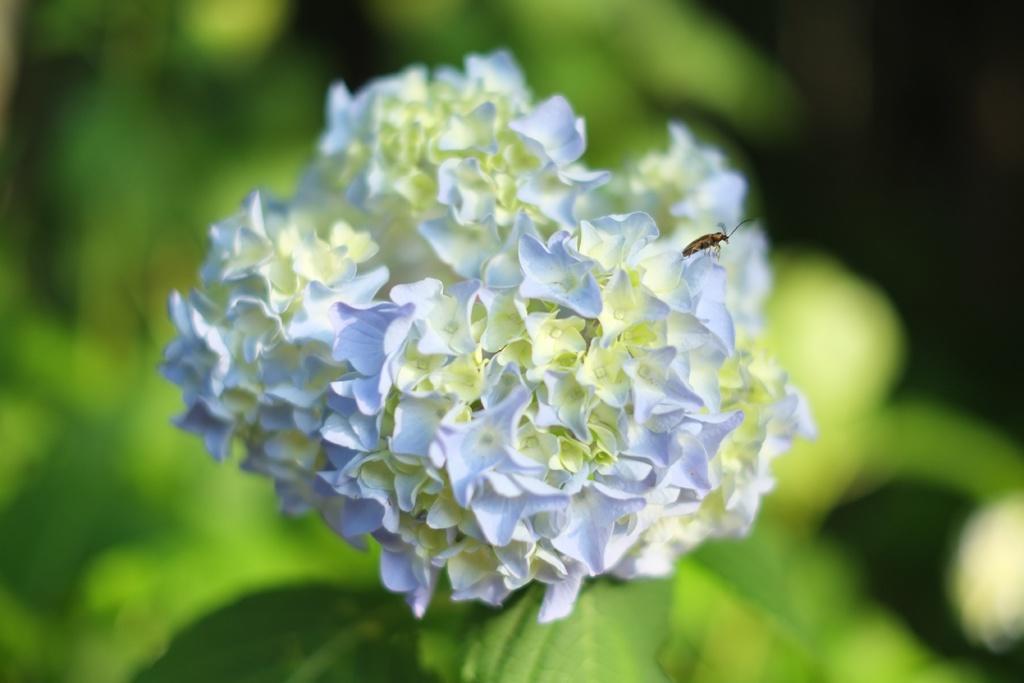How would you summarize this image in a sentence or two? Here we can see an insect on the flowers. There is a blur background with greenery. 